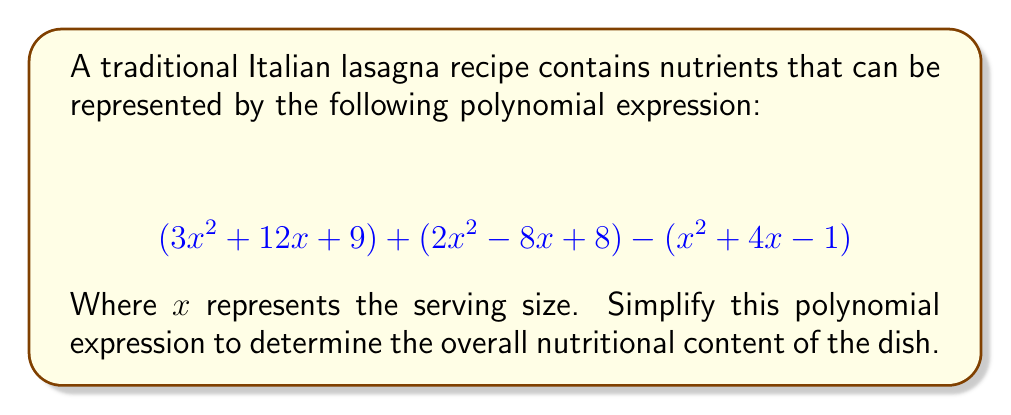Can you solve this math problem? To simplify this polynomial expression, we need to combine like terms. Let's approach this step-by-step:

1) First, let's group like terms together:
   $$(3x^2 + 12x + 9) + (2x^2 - 8x + 8) - (x^2 + 4x - 1)$$
   $$= (3x^2 + 2x^2 - x^2) + (12x - 8x - 4x) + (9 + 8 + 1)$$

2) Now, let's simplify each group:
   
   For $x^2$ terms: $3x^2 + 2x^2 - x^2 = 4x^2$
   
   For $x$ terms: $12x - 8x - 4x = 0$
   
   For constant terms: $9 + 8 + 1 = 18$

3) Combining these simplified terms:
   $$4x^2 + 0x + 18$$

4) Since the coefficient of $x$ is zero, we can omit this term entirely.

Therefore, the simplified expression is $4x^2 + 18$.
Answer: $$4x^2 + 18$$ 